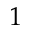Convert formula to latex. <formula><loc_0><loc_0><loc_500><loc_500>1</formula> 